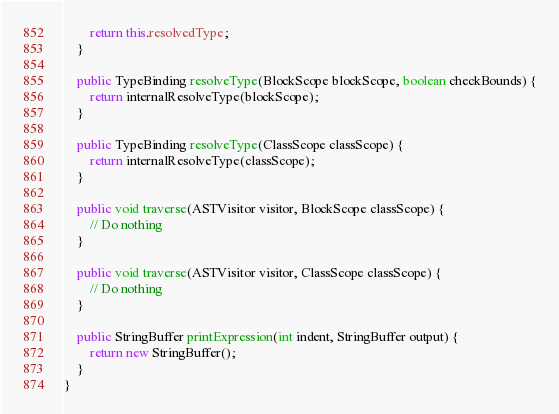Convert code to text. <code><loc_0><loc_0><loc_500><loc_500><_Java_>		return this.resolvedType;
	}

	public TypeBinding resolveType(BlockScope blockScope, boolean checkBounds) {
		return internalResolveType(blockScope);
	}

	public TypeBinding resolveType(ClassScope classScope) {
		return internalResolveType(classScope);
	}

	public void traverse(ASTVisitor visitor, BlockScope classScope) {
		// Do nothing
	}

	public void traverse(ASTVisitor visitor, ClassScope classScope) {
		// Do nothing
	}

	public StringBuffer printExpression(int indent, StringBuffer output) {
		return new StringBuffer();
	}
}
</code> 